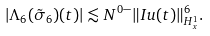<formula> <loc_0><loc_0><loc_500><loc_500>\left | \Lambda _ { 6 } ( \tilde { \sigma } _ { 6 } ) ( t ) \right | \lesssim N ^ { 0 - } \| I u ( t ) \| ^ { 6 } _ { H ^ { 1 } _ { x } } .</formula> 